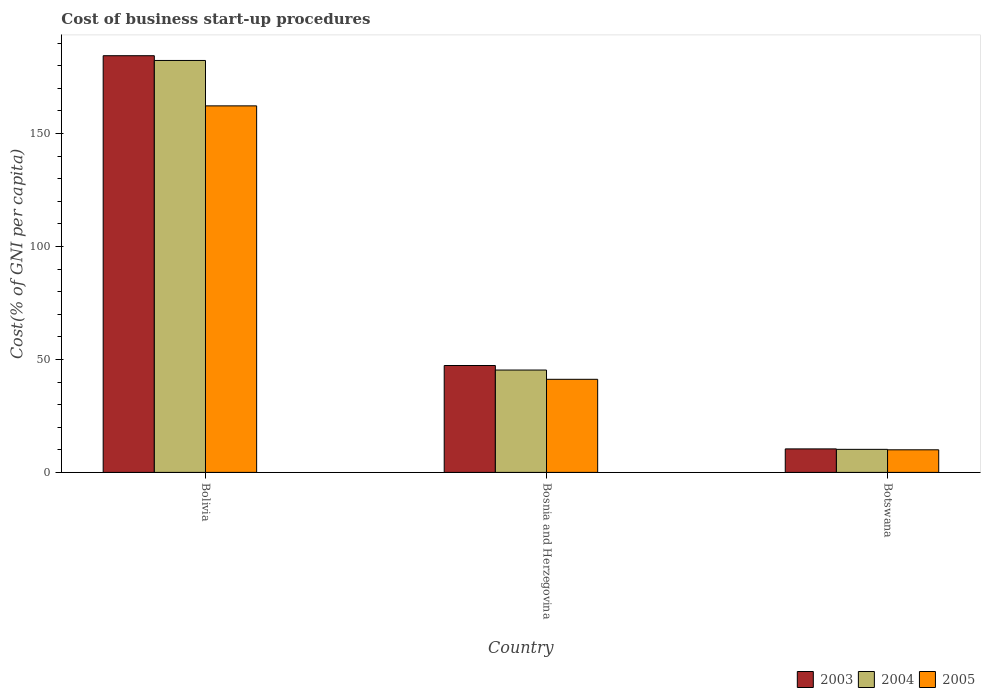How many different coloured bars are there?
Make the answer very short. 3. How many groups of bars are there?
Keep it short and to the point. 3. Are the number of bars on each tick of the X-axis equal?
Make the answer very short. Yes. How many bars are there on the 2nd tick from the left?
Provide a short and direct response. 3. What is the label of the 3rd group of bars from the left?
Provide a succinct answer. Botswana. In how many cases, is the number of bars for a given country not equal to the number of legend labels?
Keep it short and to the point. 0. What is the cost of business start-up procedures in 2003 in Bolivia?
Provide a succinct answer. 184.4. Across all countries, what is the maximum cost of business start-up procedures in 2005?
Your answer should be compact. 162.2. Across all countries, what is the minimum cost of business start-up procedures in 2004?
Provide a short and direct response. 10.2. In which country was the cost of business start-up procedures in 2004 minimum?
Your response must be concise. Botswana. What is the total cost of business start-up procedures in 2003 in the graph?
Keep it short and to the point. 242.1. What is the difference between the cost of business start-up procedures in 2005 in Bolivia and that in Bosnia and Herzegovina?
Keep it short and to the point. 121. What is the difference between the cost of business start-up procedures in 2004 in Bosnia and Herzegovina and the cost of business start-up procedures in 2003 in Bolivia?
Ensure brevity in your answer.  -139.1. What is the average cost of business start-up procedures in 2004 per country?
Your answer should be compact. 79.27. What is the difference between the cost of business start-up procedures of/in 2004 and cost of business start-up procedures of/in 2003 in Botswana?
Your answer should be very brief. -0.2. In how many countries, is the cost of business start-up procedures in 2004 greater than 100 %?
Offer a very short reply. 1. What is the ratio of the cost of business start-up procedures in 2003 in Bolivia to that in Botswana?
Offer a terse response. 17.73. What is the difference between the highest and the second highest cost of business start-up procedures in 2003?
Your answer should be compact. 174. What is the difference between the highest and the lowest cost of business start-up procedures in 2003?
Your response must be concise. 174. What does the 1st bar from the left in Botswana represents?
Give a very brief answer. 2003. Is it the case that in every country, the sum of the cost of business start-up procedures in 2003 and cost of business start-up procedures in 2004 is greater than the cost of business start-up procedures in 2005?
Provide a succinct answer. Yes. Are all the bars in the graph horizontal?
Keep it short and to the point. No. Are the values on the major ticks of Y-axis written in scientific E-notation?
Provide a short and direct response. No. Does the graph contain any zero values?
Give a very brief answer. No. Does the graph contain grids?
Offer a terse response. No. Where does the legend appear in the graph?
Keep it short and to the point. Bottom right. How many legend labels are there?
Give a very brief answer. 3. How are the legend labels stacked?
Your response must be concise. Horizontal. What is the title of the graph?
Your answer should be very brief. Cost of business start-up procedures. What is the label or title of the X-axis?
Provide a short and direct response. Country. What is the label or title of the Y-axis?
Your answer should be very brief. Cost(% of GNI per capita). What is the Cost(% of GNI per capita) of 2003 in Bolivia?
Give a very brief answer. 184.4. What is the Cost(% of GNI per capita) in 2004 in Bolivia?
Offer a terse response. 182.3. What is the Cost(% of GNI per capita) of 2005 in Bolivia?
Offer a terse response. 162.2. What is the Cost(% of GNI per capita) of 2003 in Bosnia and Herzegovina?
Your answer should be compact. 47.3. What is the Cost(% of GNI per capita) of 2004 in Bosnia and Herzegovina?
Your response must be concise. 45.3. What is the Cost(% of GNI per capita) in 2005 in Bosnia and Herzegovina?
Ensure brevity in your answer.  41.2. Across all countries, what is the maximum Cost(% of GNI per capita) in 2003?
Keep it short and to the point. 184.4. Across all countries, what is the maximum Cost(% of GNI per capita) of 2004?
Offer a terse response. 182.3. Across all countries, what is the maximum Cost(% of GNI per capita) in 2005?
Your response must be concise. 162.2. What is the total Cost(% of GNI per capita) in 2003 in the graph?
Your answer should be very brief. 242.1. What is the total Cost(% of GNI per capita) of 2004 in the graph?
Offer a very short reply. 237.8. What is the total Cost(% of GNI per capita) of 2005 in the graph?
Give a very brief answer. 213.4. What is the difference between the Cost(% of GNI per capita) in 2003 in Bolivia and that in Bosnia and Herzegovina?
Give a very brief answer. 137.1. What is the difference between the Cost(% of GNI per capita) of 2004 in Bolivia and that in Bosnia and Herzegovina?
Your response must be concise. 137. What is the difference between the Cost(% of GNI per capita) in 2005 in Bolivia and that in Bosnia and Herzegovina?
Give a very brief answer. 121. What is the difference between the Cost(% of GNI per capita) of 2003 in Bolivia and that in Botswana?
Your answer should be compact. 174. What is the difference between the Cost(% of GNI per capita) of 2004 in Bolivia and that in Botswana?
Provide a succinct answer. 172.1. What is the difference between the Cost(% of GNI per capita) of 2005 in Bolivia and that in Botswana?
Your response must be concise. 152.2. What is the difference between the Cost(% of GNI per capita) of 2003 in Bosnia and Herzegovina and that in Botswana?
Your answer should be compact. 36.9. What is the difference between the Cost(% of GNI per capita) in 2004 in Bosnia and Herzegovina and that in Botswana?
Your response must be concise. 35.1. What is the difference between the Cost(% of GNI per capita) in 2005 in Bosnia and Herzegovina and that in Botswana?
Your answer should be compact. 31.2. What is the difference between the Cost(% of GNI per capita) of 2003 in Bolivia and the Cost(% of GNI per capita) of 2004 in Bosnia and Herzegovina?
Your answer should be compact. 139.1. What is the difference between the Cost(% of GNI per capita) in 2003 in Bolivia and the Cost(% of GNI per capita) in 2005 in Bosnia and Herzegovina?
Offer a very short reply. 143.2. What is the difference between the Cost(% of GNI per capita) of 2004 in Bolivia and the Cost(% of GNI per capita) of 2005 in Bosnia and Herzegovina?
Make the answer very short. 141.1. What is the difference between the Cost(% of GNI per capita) of 2003 in Bolivia and the Cost(% of GNI per capita) of 2004 in Botswana?
Offer a very short reply. 174.2. What is the difference between the Cost(% of GNI per capita) of 2003 in Bolivia and the Cost(% of GNI per capita) of 2005 in Botswana?
Keep it short and to the point. 174.4. What is the difference between the Cost(% of GNI per capita) in 2004 in Bolivia and the Cost(% of GNI per capita) in 2005 in Botswana?
Keep it short and to the point. 172.3. What is the difference between the Cost(% of GNI per capita) in 2003 in Bosnia and Herzegovina and the Cost(% of GNI per capita) in 2004 in Botswana?
Provide a short and direct response. 37.1. What is the difference between the Cost(% of GNI per capita) in 2003 in Bosnia and Herzegovina and the Cost(% of GNI per capita) in 2005 in Botswana?
Ensure brevity in your answer.  37.3. What is the difference between the Cost(% of GNI per capita) of 2004 in Bosnia and Herzegovina and the Cost(% of GNI per capita) of 2005 in Botswana?
Your answer should be very brief. 35.3. What is the average Cost(% of GNI per capita) in 2003 per country?
Your response must be concise. 80.7. What is the average Cost(% of GNI per capita) of 2004 per country?
Give a very brief answer. 79.27. What is the average Cost(% of GNI per capita) in 2005 per country?
Keep it short and to the point. 71.13. What is the difference between the Cost(% of GNI per capita) in 2003 and Cost(% of GNI per capita) in 2004 in Bolivia?
Provide a succinct answer. 2.1. What is the difference between the Cost(% of GNI per capita) in 2003 and Cost(% of GNI per capita) in 2005 in Bolivia?
Provide a short and direct response. 22.2. What is the difference between the Cost(% of GNI per capita) in 2004 and Cost(% of GNI per capita) in 2005 in Bolivia?
Ensure brevity in your answer.  20.1. What is the difference between the Cost(% of GNI per capita) in 2003 and Cost(% of GNI per capita) in 2004 in Bosnia and Herzegovina?
Provide a succinct answer. 2. What is the difference between the Cost(% of GNI per capita) in 2003 and Cost(% of GNI per capita) in 2005 in Bosnia and Herzegovina?
Make the answer very short. 6.1. What is the ratio of the Cost(% of GNI per capita) in 2003 in Bolivia to that in Bosnia and Herzegovina?
Your response must be concise. 3.9. What is the ratio of the Cost(% of GNI per capita) of 2004 in Bolivia to that in Bosnia and Herzegovina?
Provide a succinct answer. 4.02. What is the ratio of the Cost(% of GNI per capita) in 2005 in Bolivia to that in Bosnia and Herzegovina?
Offer a terse response. 3.94. What is the ratio of the Cost(% of GNI per capita) in 2003 in Bolivia to that in Botswana?
Your answer should be compact. 17.73. What is the ratio of the Cost(% of GNI per capita) in 2004 in Bolivia to that in Botswana?
Ensure brevity in your answer.  17.87. What is the ratio of the Cost(% of GNI per capita) in 2005 in Bolivia to that in Botswana?
Your response must be concise. 16.22. What is the ratio of the Cost(% of GNI per capita) of 2003 in Bosnia and Herzegovina to that in Botswana?
Provide a succinct answer. 4.55. What is the ratio of the Cost(% of GNI per capita) in 2004 in Bosnia and Herzegovina to that in Botswana?
Provide a succinct answer. 4.44. What is the ratio of the Cost(% of GNI per capita) of 2005 in Bosnia and Herzegovina to that in Botswana?
Your answer should be compact. 4.12. What is the difference between the highest and the second highest Cost(% of GNI per capita) of 2003?
Offer a terse response. 137.1. What is the difference between the highest and the second highest Cost(% of GNI per capita) of 2004?
Give a very brief answer. 137. What is the difference between the highest and the second highest Cost(% of GNI per capita) of 2005?
Keep it short and to the point. 121. What is the difference between the highest and the lowest Cost(% of GNI per capita) of 2003?
Offer a terse response. 174. What is the difference between the highest and the lowest Cost(% of GNI per capita) of 2004?
Your answer should be compact. 172.1. What is the difference between the highest and the lowest Cost(% of GNI per capita) in 2005?
Make the answer very short. 152.2. 